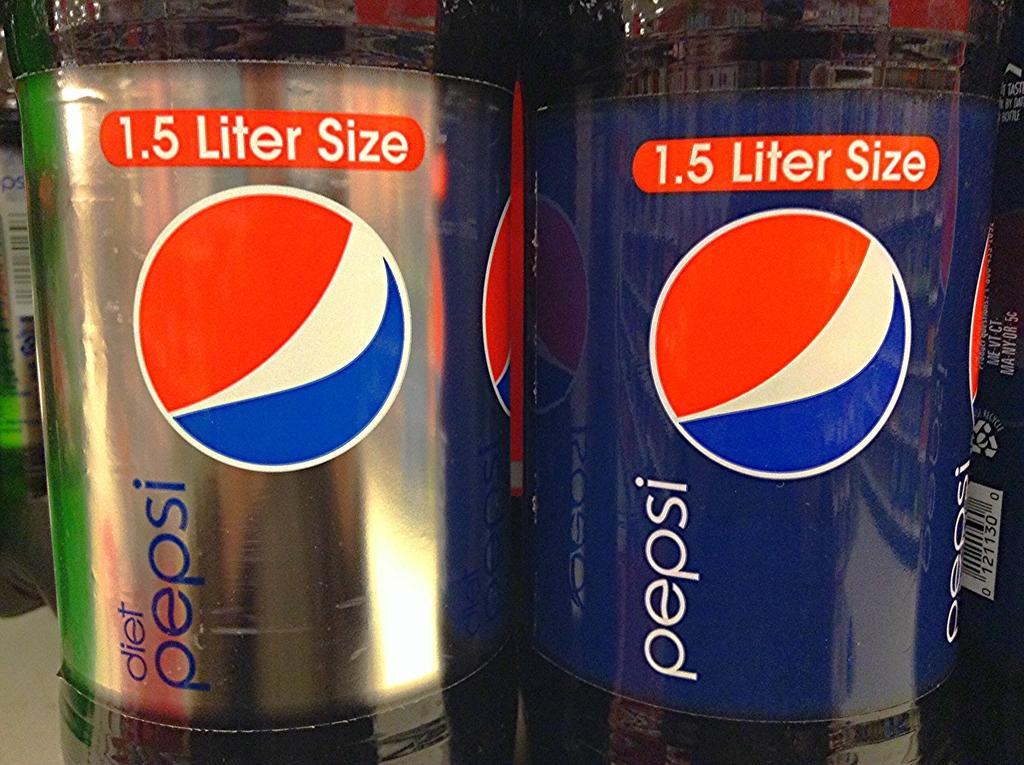<image>
Offer a succinct explanation of the picture presented. a 1.5 liter pepsi bottle is sitting beside a diet pepsi bottle 